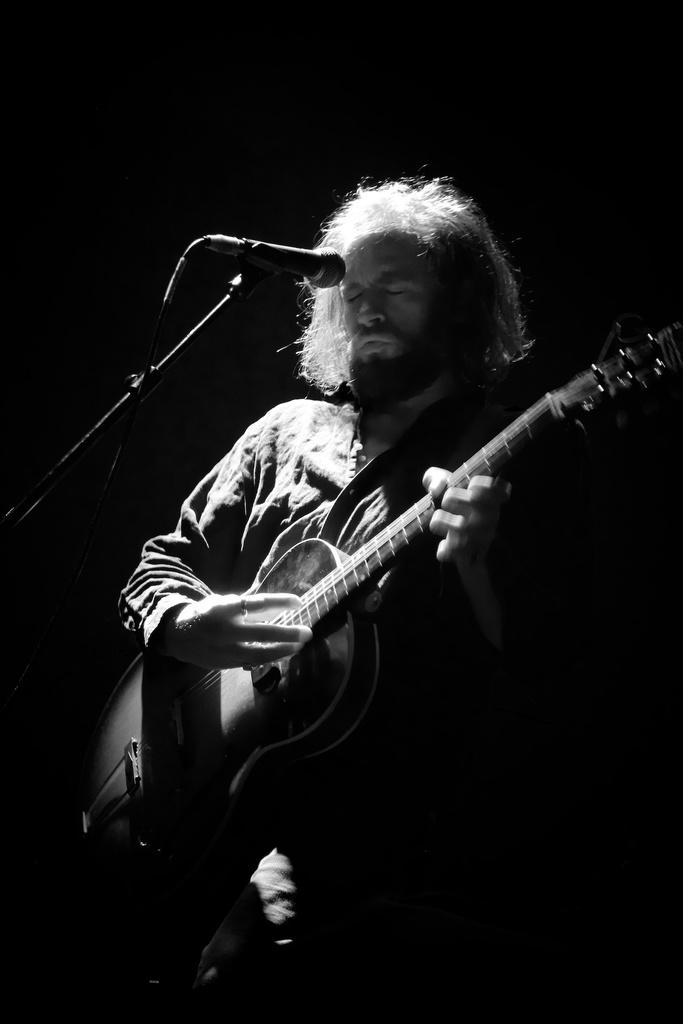What is the color scheme of the image? The image is black and white. Who is present in the image? There is a man in the image. What is the man doing in the image? The man is playing a guitar. What object is associated with the man's activity in the image? There is a microphone in the image. Can you see any carts or lawyers in the image? No, there are no carts or lawyers present in the image. Are there any fangs visible on the man in the image? No, there are no fangs visible on the man in the image. 